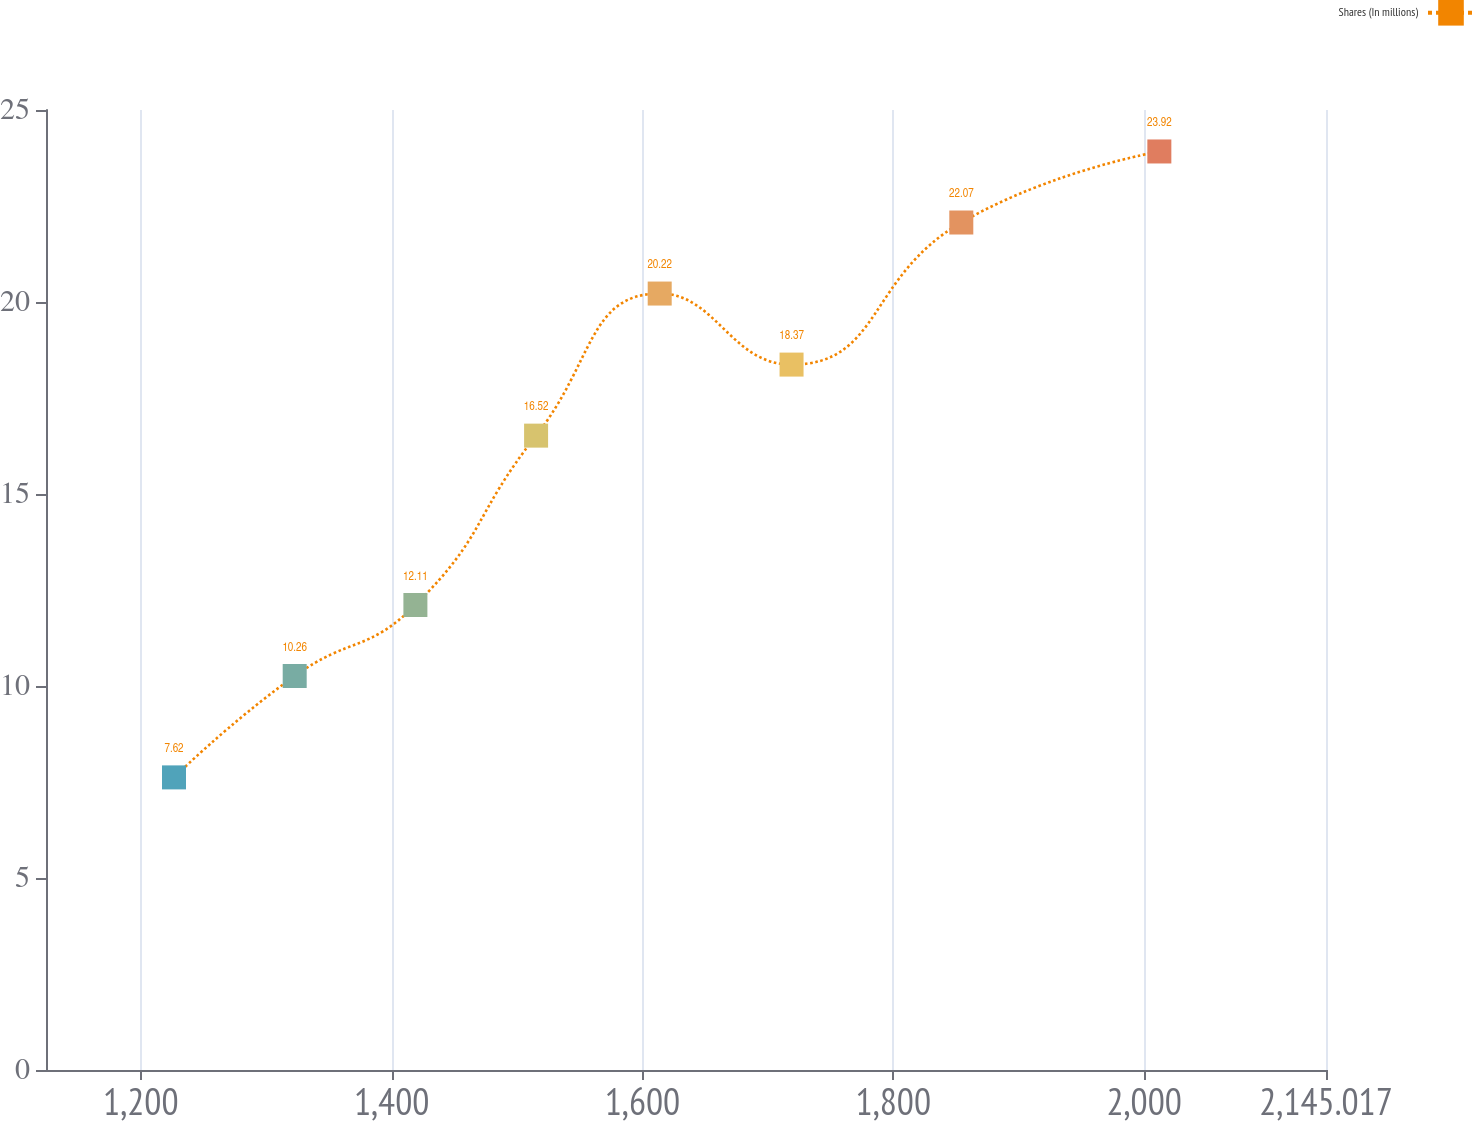Convert chart. <chart><loc_0><loc_0><loc_500><loc_500><line_chart><ecel><fcel>Shares (In millions)<nl><fcel>1226.45<fcel>7.62<nl><fcel>1322.69<fcel>10.26<nl><fcel>1418.93<fcel>12.11<nl><fcel>1515.17<fcel>16.52<nl><fcel>1613.73<fcel>20.22<nl><fcel>1718.87<fcel>18.37<nl><fcel>1854.22<fcel>22.07<nl><fcel>2012.13<fcel>23.92<nl><fcel>2150.84<fcel>27.87<nl><fcel>2247.08<fcel>26.02<nl></chart> 